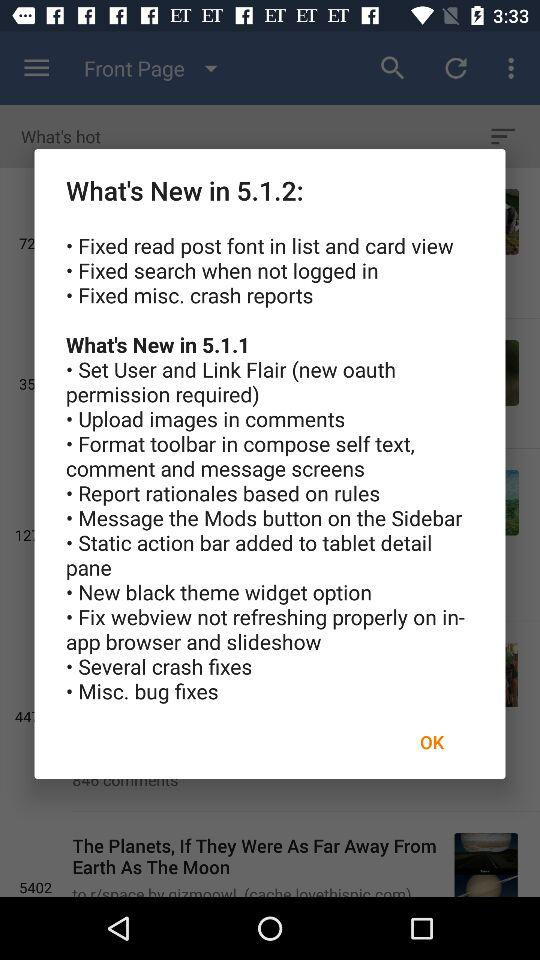What is the latest version of the application being used? The latest version is 5.1.2. 